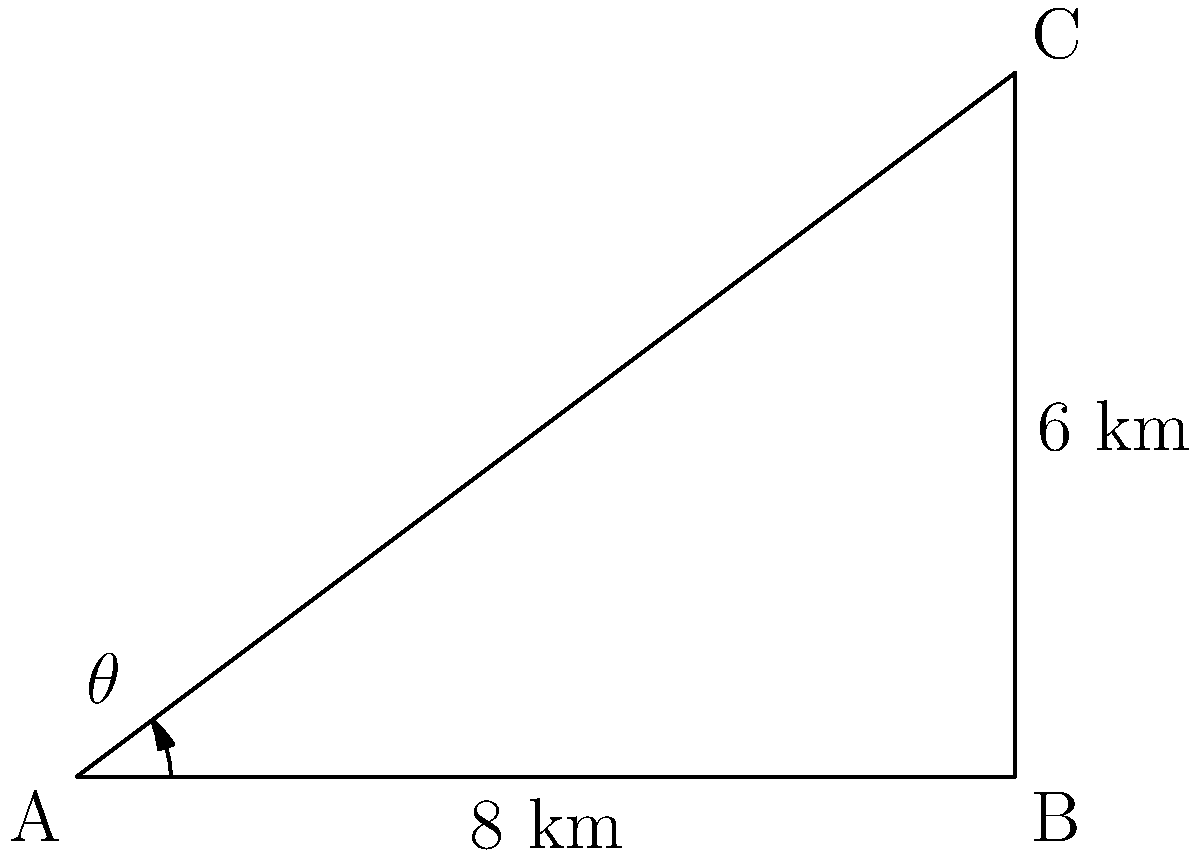Two activist groups are marching on intersecting streets in a city. Group A starts at point A and marches 8 km east to point B. Group B starts at point A and marches in a direction that forms an angle $\theta$ with the east direction. If the distance between the two groups at the end of their marches is 6 km, what is the distance that Group B marched? Round your answer to the nearest tenth of a kilometer. Let's approach this step-by-step using trigonometry:

1) We can see that this forms a right-angled triangle ABC, where:
   - AB = 8 km (Group A's march)
   - BC = 6 km (Distance between groups at the end)
   - AC = distance Group B marched (what we're solving for)

2) We can use the Pythagorean theorem to find AC:

   $AC^2 = AB^2 + BC^2$

3) Substituting the known values:

   $AC^2 = 8^2 + 6^2 = 64 + 36 = 100$

4) Taking the square root of both sides:

   $AC = \sqrt{100} = 10$

5) Therefore, Group B marched 10 km.

This solution demonstrates how incremental progress in mathematics (using known formulas and step-by-step problem-solving) can effectively solve complex real-world problems, aligning with the persona's belief in incremental progress.
Answer: 10.0 km 